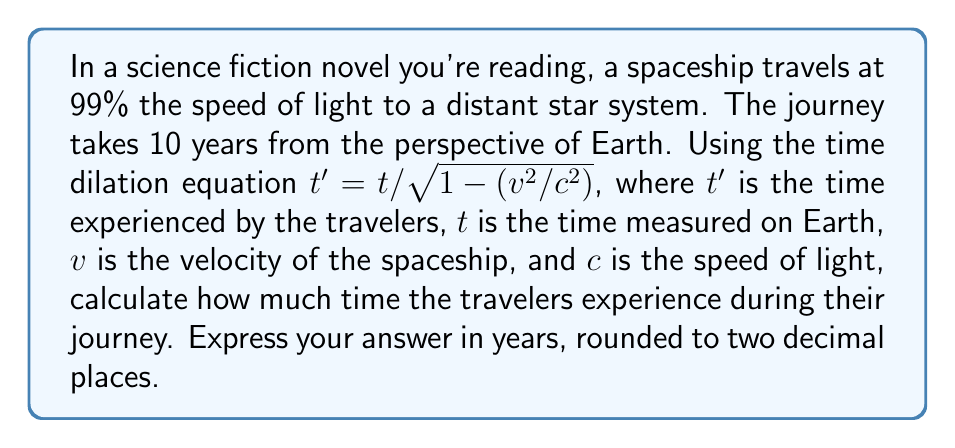Give your solution to this math problem. Let's approach this step-by-step:

1) We're given:
   $t = 10$ years (Earth time)
   $v = 0.99c$ (99% of light speed)
   $c = 1$ (we can use $c=1$ for simplification)

2) We'll use the time dilation equation:
   $t' = t / \sqrt{1 - (v^2/c^2)}$

3) First, let's calculate $v^2/c^2$:
   $v^2/c^2 = (0.99c)^2/c^2 = 0.99^2 = 0.9801$

4) Now, let's calculate $1 - (v^2/c^2)$:
   $1 - 0.9801 = 0.0199$

5) Next, we'll find the square root of this value:
   $\sqrt{0.0199} \approx 0.1411$

6) Finally, we can calculate $t'$:
   $t' = 10 / 0.1411 \approx 70.87$ years

7) Rounding to two decimal places:
   $t' \approx 70.87$ years
Answer: $70.87$ years 